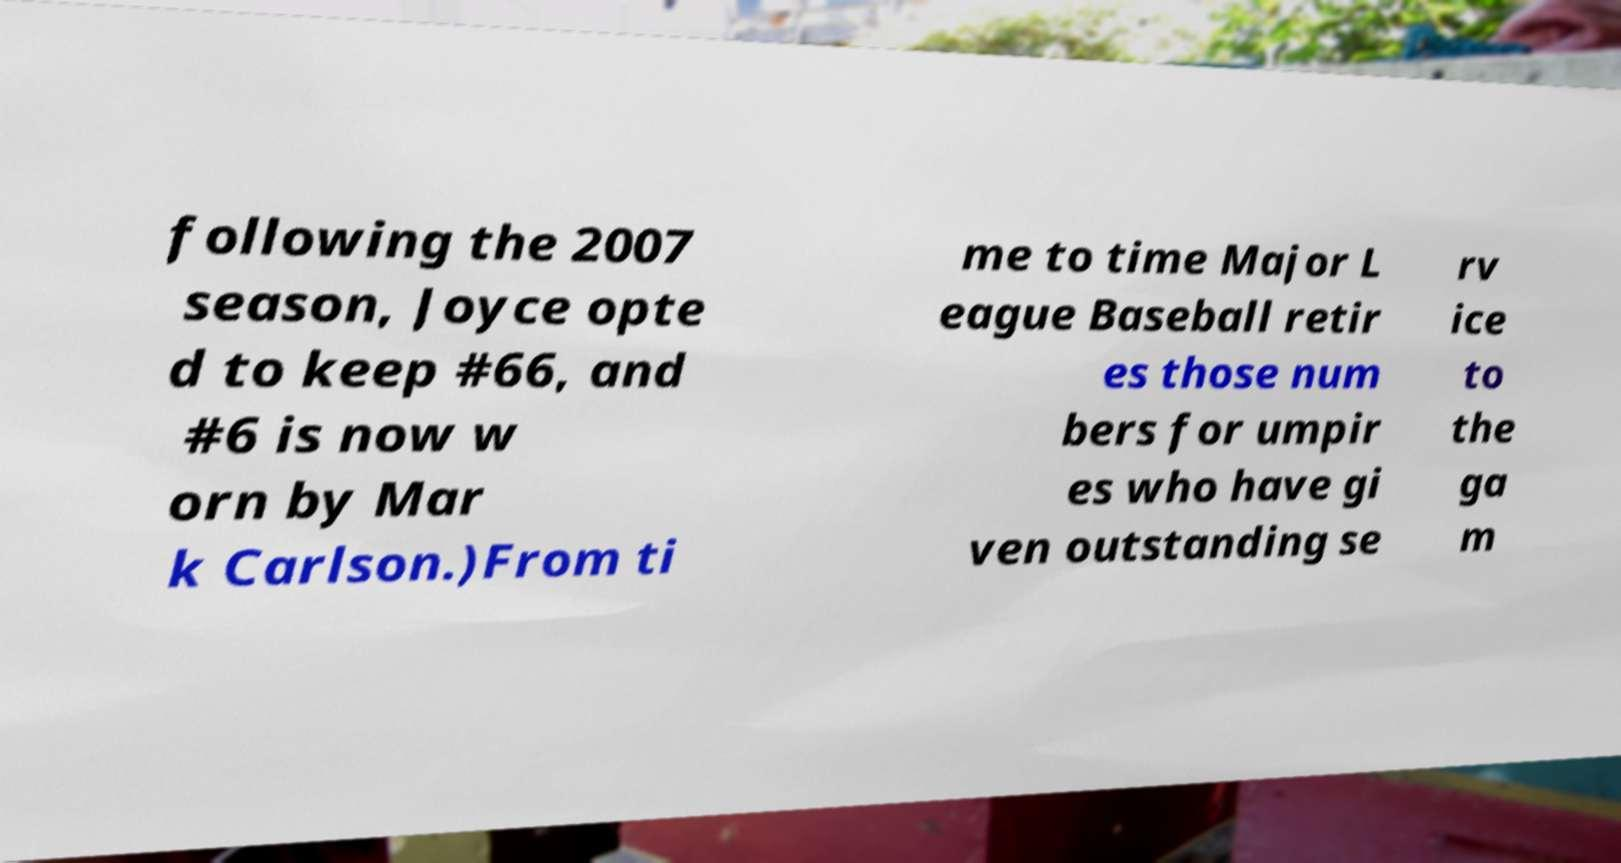There's text embedded in this image that I need extracted. Can you transcribe it verbatim? following the 2007 season, Joyce opte d to keep #66, and #6 is now w orn by Mar k Carlson.)From ti me to time Major L eague Baseball retir es those num bers for umpir es who have gi ven outstanding se rv ice to the ga m 